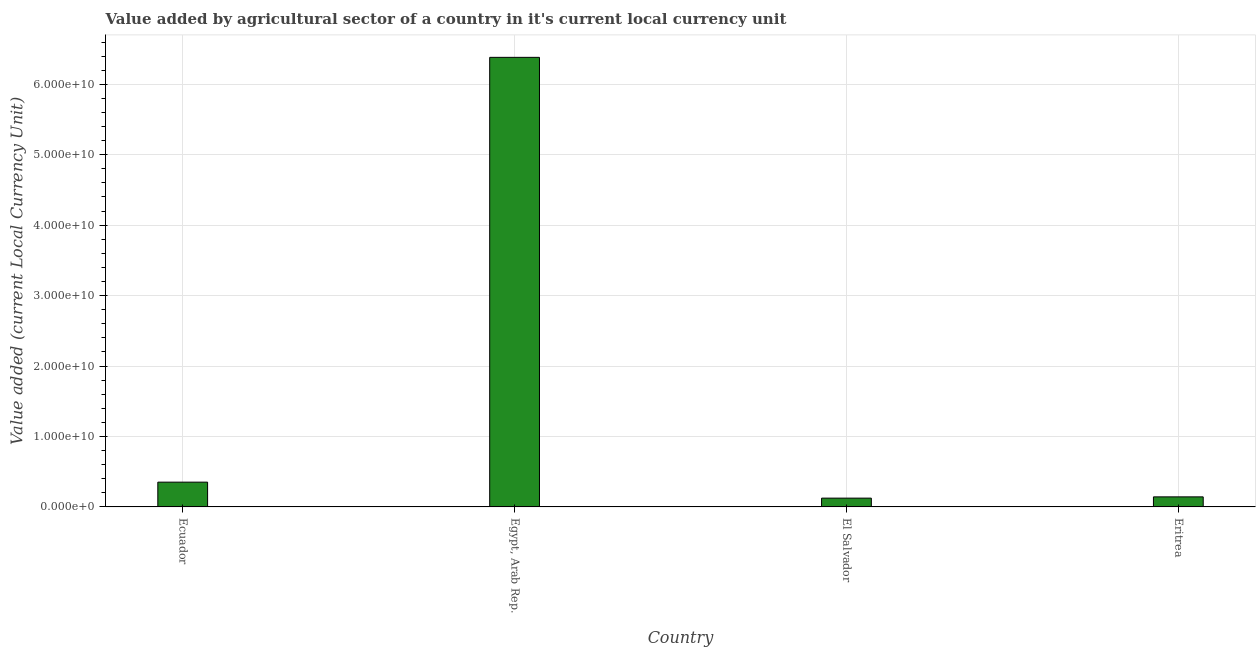Does the graph contain grids?
Ensure brevity in your answer.  Yes. What is the title of the graph?
Make the answer very short. Value added by agricultural sector of a country in it's current local currency unit. What is the label or title of the Y-axis?
Offer a very short reply. Value added (current Local Currency Unit). What is the value added by agriculture sector in Eritrea?
Your answer should be very brief. 1.43e+09. Across all countries, what is the maximum value added by agriculture sector?
Provide a short and direct response. 6.38e+1. Across all countries, what is the minimum value added by agriculture sector?
Offer a very short reply. 1.25e+09. In which country was the value added by agriculture sector maximum?
Offer a very short reply. Egypt, Arab Rep. In which country was the value added by agriculture sector minimum?
Your answer should be very brief. El Salvador. What is the sum of the value added by agriculture sector?
Your answer should be compact. 7.00e+1. What is the difference between the value added by agriculture sector in Egypt, Arab Rep. and Eritrea?
Offer a very short reply. 6.24e+1. What is the average value added by agriculture sector per country?
Provide a short and direct response. 1.75e+1. What is the median value added by agriculture sector?
Make the answer very short. 2.47e+09. What is the ratio of the value added by agriculture sector in Egypt, Arab Rep. to that in El Salvador?
Keep it short and to the point. 51.1. Is the value added by agriculture sector in Egypt, Arab Rep. less than that in El Salvador?
Your response must be concise. No. Is the difference between the value added by agriculture sector in Ecuador and Egypt, Arab Rep. greater than the difference between any two countries?
Provide a short and direct response. No. What is the difference between the highest and the second highest value added by agriculture sector?
Offer a very short reply. 6.03e+1. Is the sum of the value added by agriculture sector in Egypt, Arab Rep. and Eritrea greater than the maximum value added by agriculture sector across all countries?
Your answer should be very brief. Yes. What is the difference between the highest and the lowest value added by agriculture sector?
Provide a short and direct response. 6.26e+1. In how many countries, is the value added by agriculture sector greater than the average value added by agriculture sector taken over all countries?
Ensure brevity in your answer.  1. How many bars are there?
Make the answer very short. 4. What is the difference between two consecutive major ticks on the Y-axis?
Your answer should be very brief. 1.00e+1. What is the Value added (current Local Currency Unit) of Ecuador?
Offer a very short reply. 3.52e+09. What is the Value added (current Local Currency Unit) of Egypt, Arab Rep.?
Your answer should be compact. 6.38e+1. What is the Value added (current Local Currency Unit) in El Salvador?
Offer a terse response. 1.25e+09. What is the Value added (current Local Currency Unit) in Eritrea?
Offer a terse response. 1.43e+09. What is the difference between the Value added (current Local Currency Unit) in Ecuador and Egypt, Arab Rep.?
Make the answer very short. -6.03e+1. What is the difference between the Value added (current Local Currency Unit) in Ecuador and El Salvador?
Your answer should be compact. 2.27e+09. What is the difference between the Value added (current Local Currency Unit) in Ecuador and Eritrea?
Your answer should be very brief. 2.09e+09. What is the difference between the Value added (current Local Currency Unit) in Egypt, Arab Rep. and El Salvador?
Provide a short and direct response. 6.26e+1. What is the difference between the Value added (current Local Currency Unit) in Egypt, Arab Rep. and Eritrea?
Your answer should be compact. 6.24e+1. What is the difference between the Value added (current Local Currency Unit) in El Salvador and Eritrea?
Your answer should be very brief. -1.80e+08. What is the ratio of the Value added (current Local Currency Unit) in Ecuador to that in Egypt, Arab Rep.?
Offer a very short reply. 0.06. What is the ratio of the Value added (current Local Currency Unit) in Ecuador to that in El Salvador?
Ensure brevity in your answer.  2.82. What is the ratio of the Value added (current Local Currency Unit) in Ecuador to that in Eritrea?
Offer a very short reply. 2.46. What is the ratio of the Value added (current Local Currency Unit) in Egypt, Arab Rep. to that in El Salvador?
Give a very brief answer. 51.1. What is the ratio of the Value added (current Local Currency Unit) in Egypt, Arab Rep. to that in Eritrea?
Provide a succinct answer. 44.67. What is the ratio of the Value added (current Local Currency Unit) in El Salvador to that in Eritrea?
Provide a succinct answer. 0.87. 